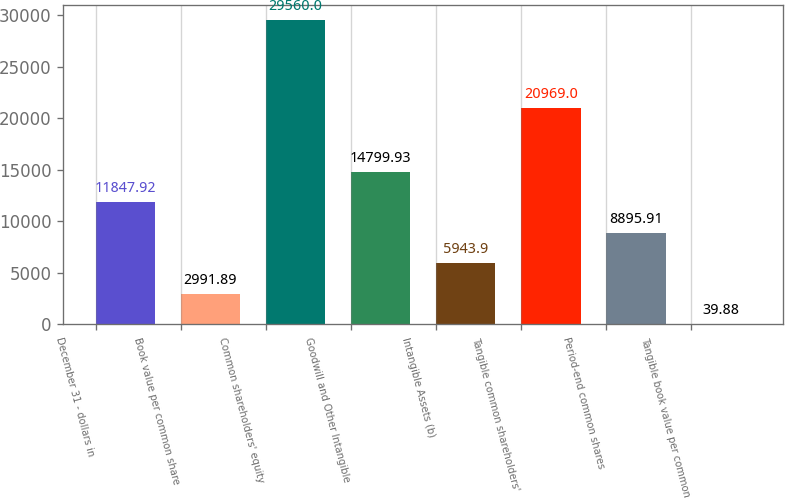<chart> <loc_0><loc_0><loc_500><loc_500><bar_chart><fcel>December 31 - dollars in<fcel>Book value per common share<fcel>Common shareholders' equity<fcel>Goodwill and Other Intangible<fcel>Intangible Assets (b)<fcel>Tangible common shareholders'<fcel>Period-end common shares<fcel>Tangible book value per common<nl><fcel>11847.9<fcel>2991.89<fcel>29560<fcel>14799.9<fcel>5943.9<fcel>20969<fcel>8895.91<fcel>39.88<nl></chart> 